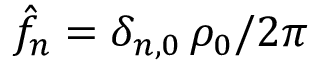Convert formula to latex. <formula><loc_0><loc_0><loc_500><loc_500>\hat { f } _ { n } = \delta _ { n , 0 } \, \rho _ { 0 } / 2 \pi</formula> 